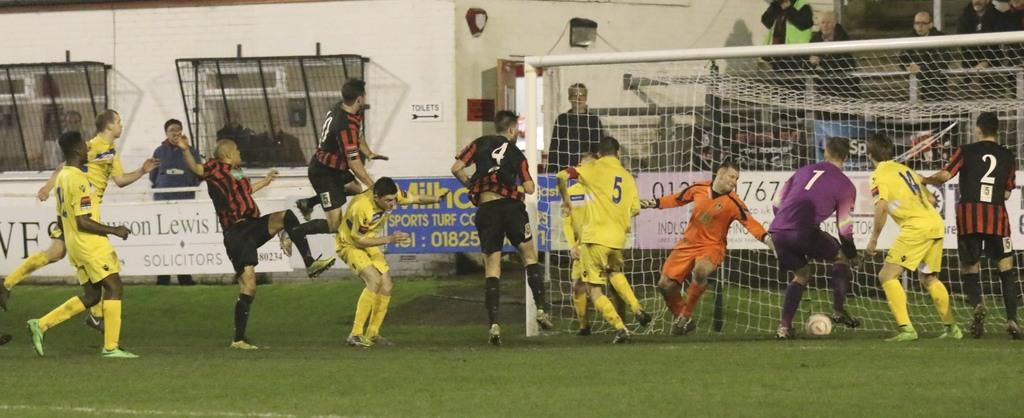What number is the player on the far right?
Keep it short and to the point. 2. What is the number of the player in purple?
Give a very brief answer. 1. 